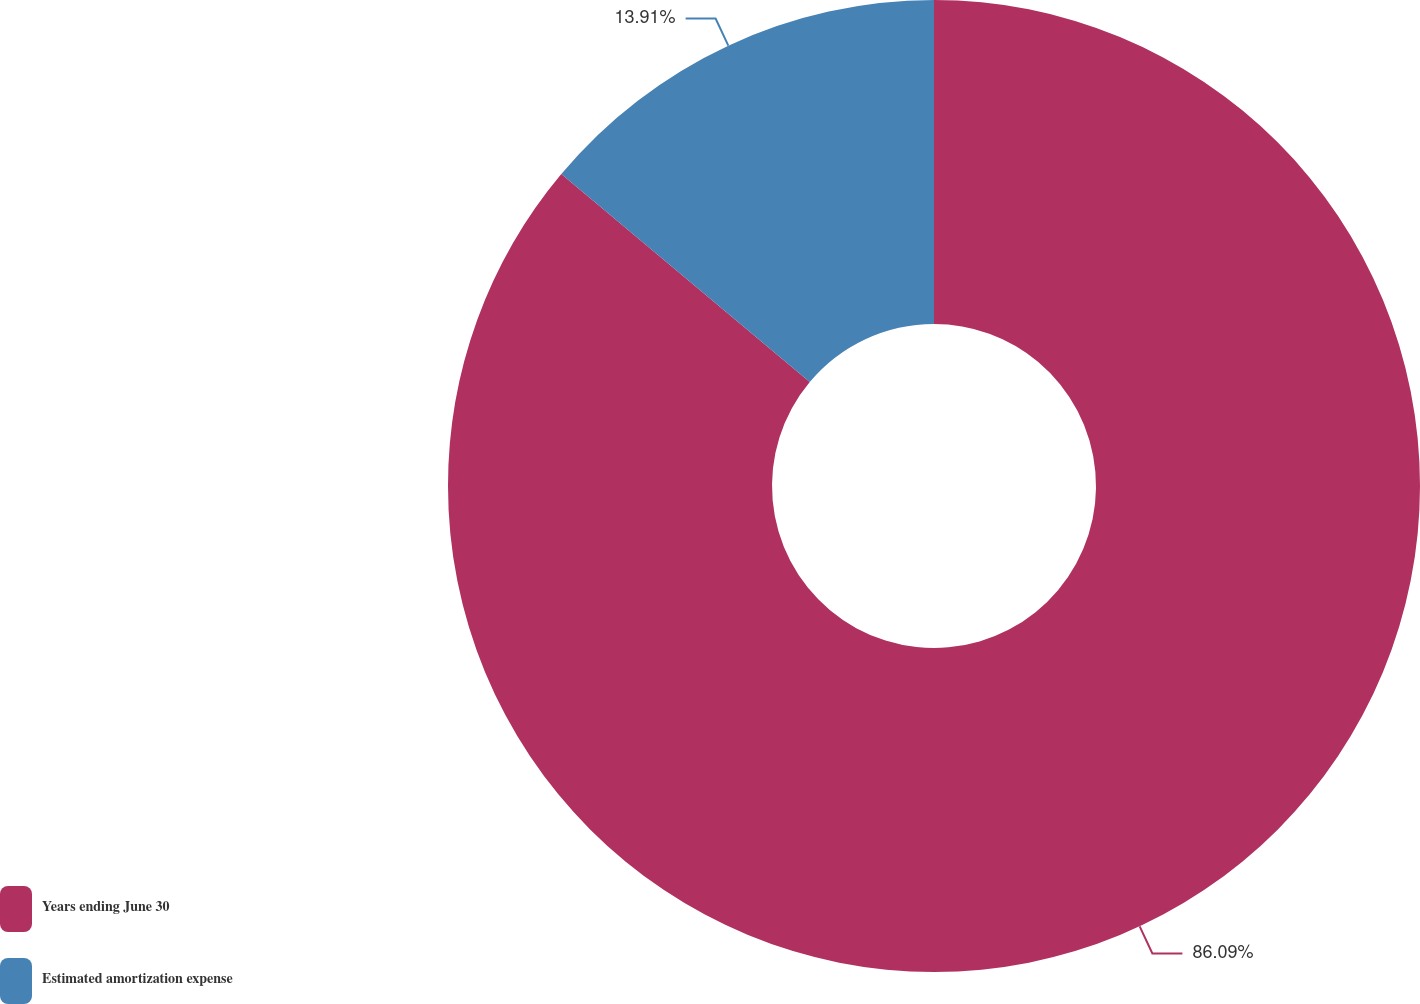<chart> <loc_0><loc_0><loc_500><loc_500><pie_chart><fcel>Years ending June 30<fcel>Estimated amortization expense<nl><fcel>86.09%<fcel>13.91%<nl></chart> 